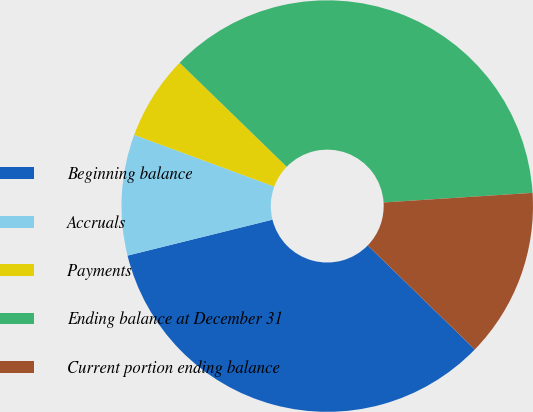Convert chart. <chart><loc_0><loc_0><loc_500><loc_500><pie_chart><fcel>Beginning balance<fcel>Accruals<fcel>Payments<fcel>Ending balance at December 31<fcel>Current portion ending balance<nl><fcel>33.86%<fcel>9.49%<fcel>6.64%<fcel>36.71%<fcel>13.29%<nl></chart> 